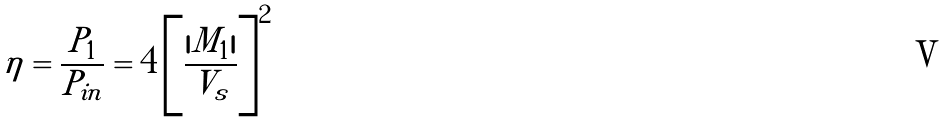Convert formula to latex. <formula><loc_0><loc_0><loc_500><loc_500>\eta = \frac { P _ { 1 } } { P _ { i n } } = 4 \left [ \frac { | M _ { 1 } | } { V _ { s } } \right ] ^ { 2 }</formula> 